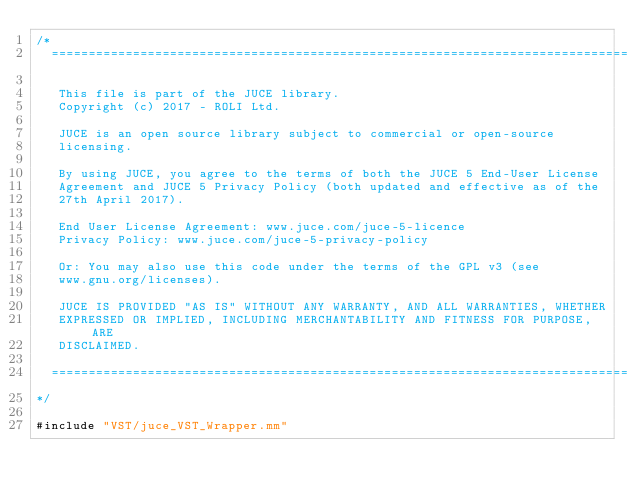<code> <loc_0><loc_0><loc_500><loc_500><_ObjectiveC_>/*
  ==============================================================================

   This file is part of the JUCE library.
   Copyright (c) 2017 - ROLI Ltd.

   JUCE is an open source library subject to commercial or open-source
   licensing.

   By using JUCE, you agree to the terms of both the JUCE 5 End-User License
   Agreement and JUCE 5 Privacy Policy (both updated and effective as of the
   27th April 2017).

   End User License Agreement: www.juce.com/juce-5-licence
   Privacy Policy: www.juce.com/juce-5-privacy-policy

   Or: You may also use this code under the terms of the GPL v3 (see
   www.gnu.org/licenses).

   JUCE IS PROVIDED "AS IS" WITHOUT ANY WARRANTY, AND ALL WARRANTIES, WHETHER
   EXPRESSED OR IMPLIED, INCLUDING MERCHANTABILITY AND FITNESS FOR PURPOSE, ARE
   DISCLAIMED.

  ==============================================================================
*/

#include "VST/juce_VST_Wrapper.mm"
</code> 